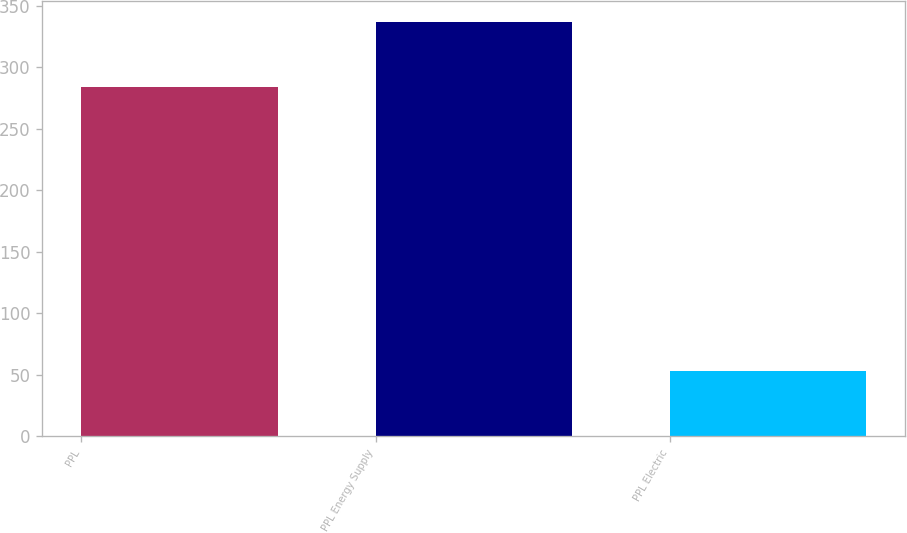Convert chart to OTSL. <chart><loc_0><loc_0><loc_500><loc_500><bar_chart><fcel>PPL<fcel>PPL Energy Supply<fcel>PPL Electric<nl><fcel>284<fcel>337<fcel>53<nl></chart> 